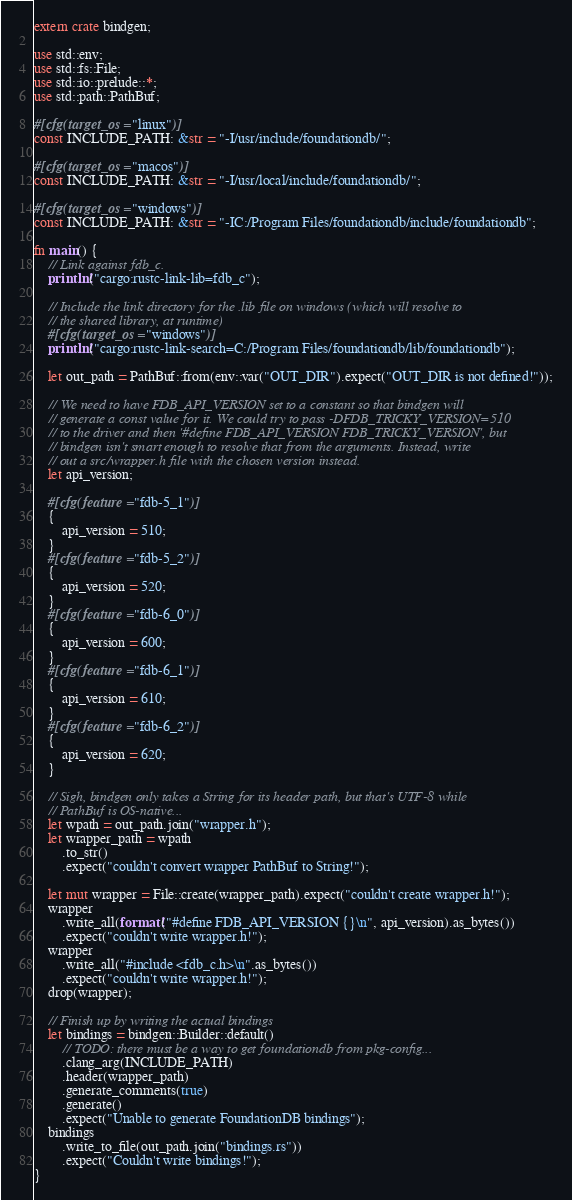Convert code to text. <code><loc_0><loc_0><loc_500><loc_500><_Rust_>extern crate bindgen;

use std::env;
use std::fs::File;
use std::io::prelude::*;
use std::path::PathBuf;

#[cfg(target_os = "linux")]
const INCLUDE_PATH: &str = "-I/usr/include/foundationdb/";

#[cfg(target_os = "macos")]
const INCLUDE_PATH: &str = "-I/usr/local/include/foundationdb/";

#[cfg(target_os = "windows")]
const INCLUDE_PATH: &str = "-IC:/Program Files/foundationdb/include/foundationdb";

fn main() {
    // Link against fdb_c.
    println!("cargo:rustc-link-lib=fdb_c");

    // Include the link directory for the .lib file on windows (which will resolve to
    // the shared library, at runtime)
    #[cfg(target_os = "windows")]
    println!("cargo:rustc-link-search=C:/Program Files/foundationdb/lib/foundationdb");

    let out_path = PathBuf::from(env::var("OUT_DIR").expect("OUT_DIR is not defined!"));

    // We need to have FDB_API_VERSION set to a constant so that bindgen will
    // generate a const value for it. We could try to pass -DFDB_TRICKY_VERSION=510
    // to the driver and then '#define FDB_API_VERSION FDB_TRICKY_VERSION', but
    // bindgen isn't smart enough to resolve that from the arguments. Instead, write
    // out a src/wrapper.h file with the chosen version instead.
    let api_version;

    #[cfg(feature = "fdb-5_1")]
    {
        api_version = 510;
    }
    #[cfg(feature = "fdb-5_2")]
    {
        api_version = 520;
    }
    #[cfg(feature = "fdb-6_0")]
    {
        api_version = 600;
    }
    #[cfg(feature = "fdb-6_1")]
    {
        api_version = 610;
    }
    #[cfg(feature = "fdb-6_2")]
    {
        api_version = 620;
    }

    // Sigh, bindgen only takes a String for its header path, but that's UTF-8 while
    // PathBuf is OS-native...
    let wpath = out_path.join("wrapper.h");
    let wrapper_path = wpath
        .to_str()
        .expect("couldn't convert wrapper PathBuf to String!");

    let mut wrapper = File::create(wrapper_path).expect("couldn't create wrapper.h!");
    wrapper
        .write_all(format!("#define FDB_API_VERSION {}\n", api_version).as_bytes())
        .expect("couldn't write wrapper.h!");
    wrapper
        .write_all("#include <fdb_c.h>\n".as_bytes())
        .expect("couldn't write wrapper.h!");
    drop(wrapper);

    // Finish up by writing the actual bindings
    let bindings = bindgen::Builder::default()
        // TODO: there must be a way to get foundationdb from pkg-config...
        .clang_arg(INCLUDE_PATH)
        .header(wrapper_path)
        .generate_comments(true)
        .generate()
        .expect("Unable to generate FoundationDB bindings");
    bindings
        .write_to_file(out_path.join("bindings.rs"))
        .expect("Couldn't write bindings!");
}
</code> 